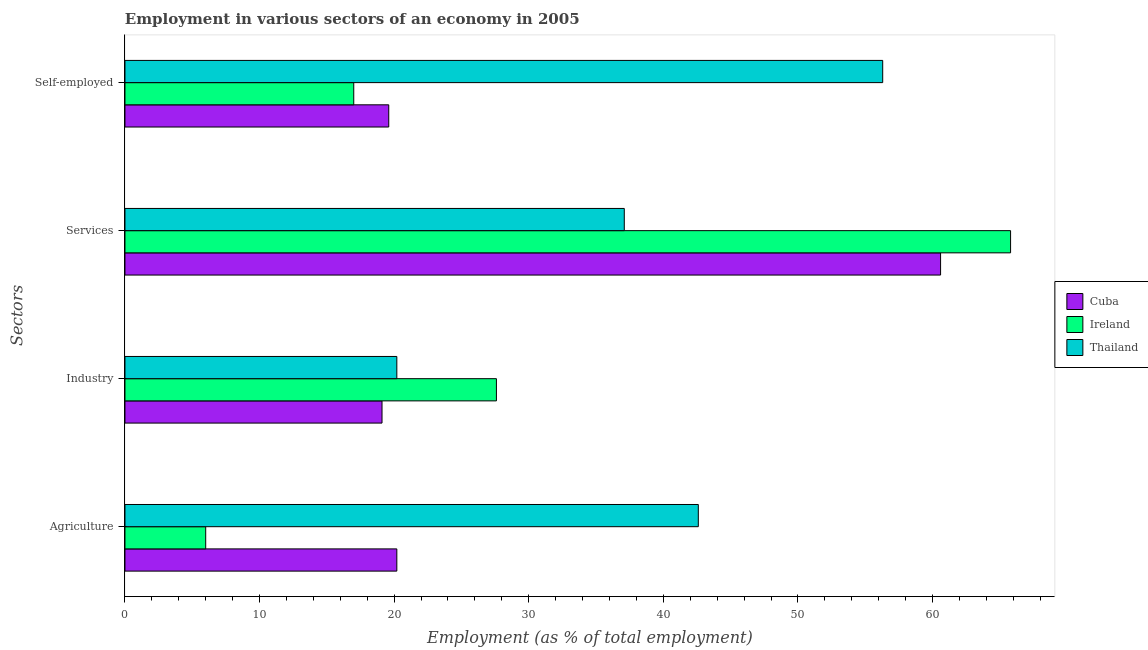How many bars are there on the 4th tick from the top?
Your answer should be compact. 3. How many bars are there on the 1st tick from the bottom?
Provide a succinct answer. 3. What is the label of the 3rd group of bars from the top?
Your response must be concise. Industry. What is the percentage of workers in industry in Ireland?
Offer a very short reply. 27.6. Across all countries, what is the maximum percentage of workers in services?
Offer a very short reply. 65.8. Across all countries, what is the minimum percentage of workers in services?
Your answer should be very brief. 37.1. In which country was the percentage of workers in services maximum?
Give a very brief answer. Ireland. In which country was the percentage of workers in industry minimum?
Keep it short and to the point. Cuba. What is the total percentage of workers in services in the graph?
Provide a short and direct response. 163.5. What is the difference between the percentage of workers in industry in Thailand and that in Ireland?
Make the answer very short. -7.4. What is the difference between the percentage of workers in agriculture in Thailand and the percentage of workers in industry in Ireland?
Provide a succinct answer. 15. What is the average percentage of workers in industry per country?
Provide a succinct answer. 22.3. What is the difference between the percentage of workers in agriculture and percentage of self employed workers in Cuba?
Give a very brief answer. 0.6. In how many countries, is the percentage of self employed workers greater than 64 %?
Keep it short and to the point. 0. What is the ratio of the percentage of workers in industry in Cuba to that in Thailand?
Provide a short and direct response. 0.95. Is the percentage of self employed workers in Ireland less than that in Cuba?
Keep it short and to the point. Yes. What is the difference between the highest and the second highest percentage of workers in agriculture?
Give a very brief answer. 22.4. What is the difference between the highest and the lowest percentage of workers in industry?
Provide a succinct answer. 8.5. In how many countries, is the percentage of workers in industry greater than the average percentage of workers in industry taken over all countries?
Give a very brief answer. 1. What does the 2nd bar from the top in Industry represents?
Make the answer very short. Ireland. What does the 3rd bar from the bottom in Self-employed represents?
Make the answer very short. Thailand. Are all the bars in the graph horizontal?
Give a very brief answer. Yes. How many countries are there in the graph?
Provide a succinct answer. 3. How are the legend labels stacked?
Ensure brevity in your answer.  Vertical. What is the title of the graph?
Ensure brevity in your answer.  Employment in various sectors of an economy in 2005. Does "Vietnam" appear as one of the legend labels in the graph?
Your answer should be very brief. No. What is the label or title of the X-axis?
Offer a very short reply. Employment (as % of total employment). What is the label or title of the Y-axis?
Make the answer very short. Sectors. What is the Employment (as % of total employment) of Cuba in Agriculture?
Ensure brevity in your answer.  20.2. What is the Employment (as % of total employment) of Thailand in Agriculture?
Keep it short and to the point. 42.6. What is the Employment (as % of total employment) in Cuba in Industry?
Keep it short and to the point. 19.1. What is the Employment (as % of total employment) of Ireland in Industry?
Give a very brief answer. 27.6. What is the Employment (as % of total employment) of Thailand in Industry?
Make the answer very short. 20.2. What is the Employment (as % of total employment) of Cuba in Services?
Ensure brevity in your answer.  60.6. What is the Employment (as % of total employment) of Ireland in Services?
Ensure brevity in your answer.  65.8. What is the Employment (as % of total employment) of Thailand in Services?
Keep it short and to the point. 37.1. What is the Employment (as % of total employment) of Cuba in Self-employed?
Your answer should be compact. 19.6. What is the Employment (as % of total employment) in Ireland in Self-employed?
Offer a very short reply. 17. What is the Employment (as % of total employment) in Thailand in Self-employed?
Offer a terse response. 56.3. Across all Sectors, what is the maximum Employment (as % of total employment) in Cuba?
Keep it short and to the point. 60.6. Across all Sectors, what is the maximum Employment (as % of total employment) in Ireland?
Your answer should be compact. 65.8. Across all Sectors, what is the maximum Employment (as % of total employment) of Thailand?
Provide a succinct answer. 56.3. Across all Sectors, what is the minimum Employment (as % of total employment) in Cuba?
Provide a short and direct response. 19.1. Across all Sectors, what is the minimum Employment (as % of total employment) in Thailand?
Offer a terse response. 20.2. What is the total Employment (as % of total employment) of Cuba in the graph?
Your answer should be very brief. 119.5. What is the total Employment (as % of total employment) of Ireland in the graph?
Provide a succinct answer. 116.4. What is the total Employment (as % of total employment) of Thailand in the graph?
Offer a very short reply. 156.2. What is the difference between the Employment (as % of total employment) of Cuba in Agriculture and that in Industry?
Make the answer very short. 1.1. What is the difference between the Employment (as % of total employment) of Ireland in Agriculture and that in Industry?
Keep it short and to the point. -21.6. What is the difference between the Employment (as % of total employment) of Thailand in Agriculture and that in Industry?
Keep it short and to the point. 22.4. What is the difference between the Employment (as % of total employment) in Cuba in Agriculture and that in Services?
Your answer should be very brief. -40.4. What is the difference between the Employment (as % of total employment) in Ireland in Agriculture and that in Services?
Your answer should be very brief. -59.8. What is the difference between the Employment (as % of total employment) of Thailand in Agriculture and that in Services?
Ensure brevity in your answer.  5.5. What is the difference between the Employment (as % of total employment) in Cuba in Agriculture and that in Self-employed?
Your answer should be very brief. 0.6. What is the difference between the Employment (as % of total employment) in Thailand in Agriculture and that in Self-employed?
Provide a short and direct response. -13.7. What is the difference between the Employment (as % of total employment) of Cuba in Industry and that in Services?
Provide a short and direct response. -41.5. What is the difference between the Employment (as % of total employment) in Ireland in Industry and that in Services?
Make the answer very short. -38.2. What is the difference between the Employment (as % of total employment) of Thailand in Industry and that in Services?
Provide a succinct answer. -16.9. What is the difference between the Employment (as % of total employment) in Cuba in Industry and that in Self-employed?
Ensure brevity in your answer.  -0.5. What is the difference between the Employment (as % of total employment) in Ireland in Industry and that in Self-employed?
Offer a very short reply. 10.6. What is the difference between the Employment (as % of total employment) of Thailand in Industry and that in Self-employed?
Your answer should be compact. -36.1. What is the difference between the Employment (as % of total employment) in Ireland in Services and that in Self-employed?
Keep it short and to the point. 48.8. What is the difference between the Employment (as % of total employment) of Thailand in Services and that in Self-employed?
Your answer should be very brief. -19.2. What is the difference between the Employment (as % of total employment) in Cuba in Agriculture and the Employment (as % of total employment) in Ireland in Industry?
Keep it short and to the point. -7.4. What is the difference between the Employment (as % of total employment) of Cuba in Agriculture and the Employment (as % of total employment) of Thailand in Industry?
Offer a terse response. 0. What is the difference between the Employment (as % of total employment) in Cuba in Agriculture and the Employment (as % of total employment) in Ireland in Services?
Your answer should be very brief. -45.6. What is the difference between the Employment (as % of total employment) in Cuba in Agriculture and the Employment (as % of total employment) in Thailand in Services?
Your answer should be very brief. -16.9. What is the difference between the Employment (as % of total employment) in Ireland in Agriculture and the Employment (as % of total employment) in Thailand in Services?
Ensure brevity in your answer.  -31.1. What is the difference between the Employment (as % of total employment) of Cuba in Agriculture and the Employment (as % of total employment) of Ireland in Self-employed?
Your response must be concise. 3.2. What is the difference between the Employment (as % of total employment) of Cuba in Agriculture and the Employment (as % of total employment) of Thailand in Self-employed?
Your response must be concise. -36.1. What is the difference between the Employment (as % of total employment) of Ireland in Agriculture and the Employment (as % of total employment) of Thailand in Self-employed?
Give a very brief answer. -50.3. What is the difference between the Employment (as % of total employment) of Cuba in Industry and the Employment (as % of total employment) of Ireland in Services?
Provide a succinct answer. -46.7. What is the difference between the Employment (as % of total employment) in Cuba in Industry and the Employment (as % of total employment) in Thailand in Services?
Offer a very short reply. -18. What is the difference between the Employment (as % of total employment) of Ireland in Industry and the Employment (as % of total employment) of Thailand in Services?
Your answer should be very brief. -9.5. What is the difference between the Employment (as % of total employment) in Cuba in Industry and the Employment (as % of total employment) in Ireland in Self-employed?
Keep it short and to the point. 2.1. What is the difference between the Employment (as % of total employment) of Cuba in Industry and the Employment (as % of total employment) of Thailand in Self-employed?
Provide a short and direct response. -37.2. What is the difference between the Employment (as % of total employment) in Ireland in Industry and the Employment (as % of total employment) in Thailand in Self-employed?
Make the answer very short. -28.7. What is the difference between the Employment (as % of total employment) of Cuba in Services and the Employment (as % of total employment) of Ireland in Self-employed?
Offer a very short reply. 43.6. What is the difference between the Employment (as % of total employment) in Ireland in Services and the Employment (as % of total employment) in Thailand in Self-employed?
Provide a short and direct response. 9.5. What is the average Employment (as % of total employment) in Cuba per Sectors?
Keep it short and to the point. 29.88. What is the average Employment (as % of total employment) of Ireland per Sectors?
Offer a terse response. 29.1. What is the average Employment (as % of total employment) of Thailand per Sectors?
Offer a terse response. 39.05. What is the difference between the Employment (as % of total employment) of Cuba and Employment (as % of total employment) of Thailand in Agriculture?
Your response must be concise. -22.4. What is the difference between the Employment (as % of total employment) in Ireland and Employment (as % of total employment) in Thailand in Agriculture?
Make the answer very short. -36.6. What is the difference between the Employment (as % of total employment) in Cuba and Employment (as % of total employment) in Ireland in Services?
Give a very brief answer. -5.2. What is the difference between the Employment (as % of total employment) in Ireland and Employment (as % of total employment) in Thailand in Services?
Offer a very short reply. 28.7. What is the difference between the Employment (as % of total employment) in Cuba and Employment (as % of total employment) in Thailand in Self-employed?
Give a very brief answer. -36.7. What is the difference between the Employment (as % of total employment) of Ireland and Employment (as % of total employment) of Thailand in Self-employed?
Your answer should be very brief. -39.3. What is the ratio of the Employment (as % of total employment) in Cuba in Agriculture to that in Industry?
Give a very brief answer. 1.06. What is the ratio of the Employment (as % of total employment) in Ireland in Agriculture to that in Industry?
Provide a succinct answer. 0.22. What is the ratio of the Employment (as % of total employment) of Thailand in Agriculture to that in Industry?
Provide a short and direct response. 2.11. What is the ratio of the Employment (as % of total employment) of Ireland in Agriculture to that in Services?
Your answer should be compact. 0.09. What is the ratio of the Employment (as % of total employment) of Thailand in Agriculture to that in Services?
Offer a terse response. 1.15. What is the ratio of the Employment (as % of total employment) of Cuba in Agriculture to that in Self-employed?
Provide a short and direct response. 1.03. What is the ratio of the Employment (as % of total employment) of Ireland in Agriculture to that in Self-employed?
Give a very brief answer. 0.35. What is the ratio of the Employment (as % of total employment) in Thailand in Agriculture to that in Self-employed?
Give a very brief answer. 0.76. What is the ratio of the Employment (as % of total employment) in Cuba in Industry to that in Services?
Give a very brief answer. 0.32. What is the ratio of the Employment (as % of total employment) in Ireland in Industry to that in Services?
Provide a succinct answer. 0.42. What is the ratio of the Employment (as % of total employment) in Thailand in Industry to that in Services?
Offer a terse response. 0.54. What is the ratio of the Employment (as % of total employment) of Cuba in Industry to that in Self-employed?
Keep it short and to the point. 0.97. What is the ratio of the Employment (as % of total employment) of Ireland in Industry to that in Self-employed?
Provide a short and direct response. 1.62. What is the ratio of the Employment (as % of total employment) in Thailand in Industry to that in Self-employed?
Your answer should be compact. 0.36. What is the ratio of the Employment (as % of total employment) of Cuba in Services to that in Self-employed?
Make the answer very short. 3.09. What is the ratio of the Employment (as % of total employment) of Ireland in Services to that in Self-employed?
Make the answer very short. 3.87. What is the ratio of the Employment (as % of total employment) of Thailand in Services to that in Self-employed?
Your answer should be compact. 0.66. What is the difference between the highest and the second highest Employment (as % of total employment) of Cuba?
Offer a very short reply. 40.4. What is the difference between the highest and the second highest Employment (as % of total employment) in Ireland?
Give a very brief answer. 38.2. What is the difference between the highest and the lowest Employment (as % of total employment) in Cuba?
Give a very brief answer. 41.5. What is the difference between the highest and the lowest Employment (as % of total employment) of Ireland?
Give a very brief answer. 59.8. What is the difference between the highest and the lowest Employment (as % of total employment) of Thailand?
Give a very brief answer. 36.1. 